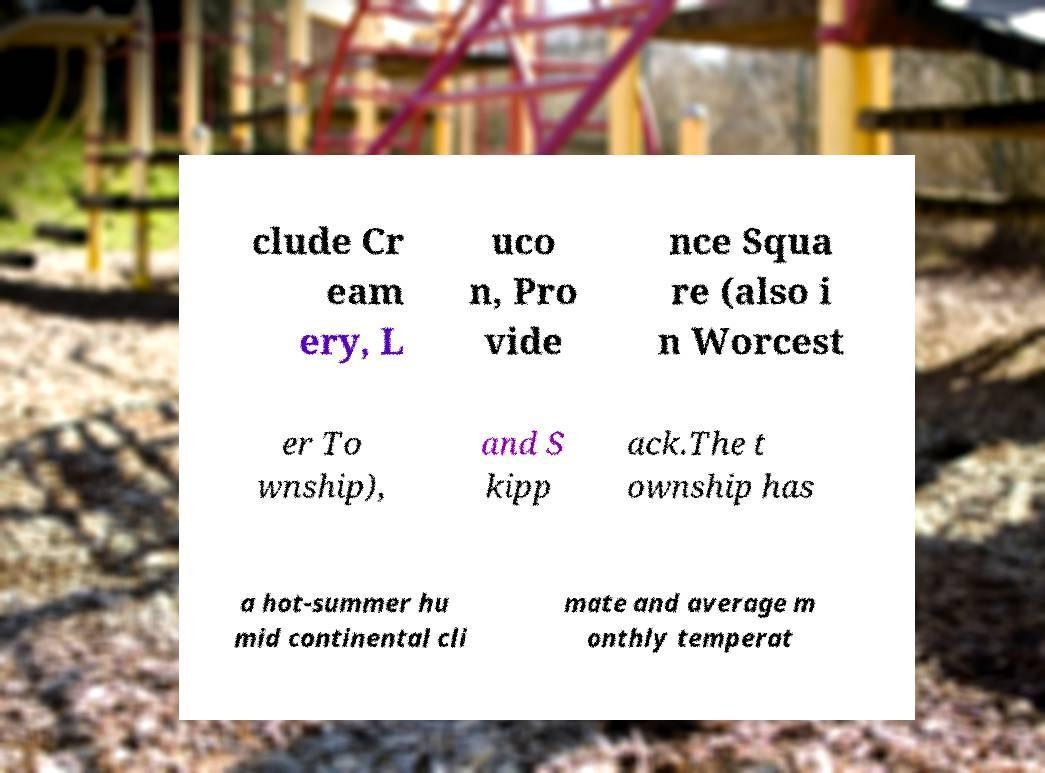Can you read and provide the text displayed in the image?This photo seems to have some interesting text. Can you extract and type it out for me? clude Cr eam ery, L uco n, Pro vide nce Squa re (also i n Worcest er To wnship), and S kipp ack.The t ownship has a hot-summer hu mid continental cli mate and average m onthly temperat 